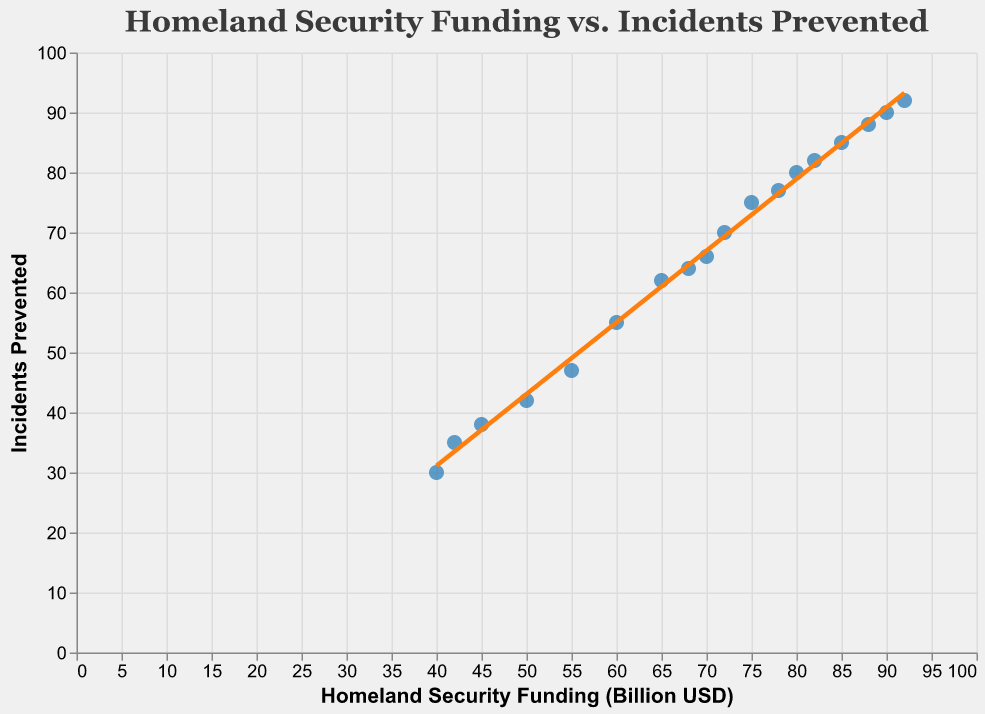How many data points are shown in the scatter plot? The scatter plot contains one data point for each fiscal year from 2005 to 2022. By counting these fiscal years, we find that there are 18 data points.
Answer: 18 What is the funding level for the year with the highest number of incidents prevented? The scatter plot shows a clear correlation where each fiscal year has increasing values for both funding and incidents prevented. The highest number of incidents prevented is 92 in 2022, where the funding is $92 billion USD.
Answer: $92 billion USD Is there any year where the incidents prevented are more than the funding in billion USD? By analyzing the data points, we observe that incidents prevented are always less than or equal to the funding provided in billion USD for each year.
Answer: No What is the trend line suggesting about the relationship between funding and incidents prevented? The trend line in the scatter plot shows a positive linear relationship, indicating that as homeland security funding increases, the number of incidents prevented also increases. The trend line enforces this correlation statistically.
Answer: Positive linear relationship Which year shows a funding of 75 billion USD and how many incidents were prevented that year? From the scatter plot, look for the data point where the x-axis shows 75 billion USD. Here, the corresponding y-axis value is 75 incidents prevented, which occurs in the year 2015.
Answer: 2015, 75 incidents How does the number of incidents prevented change from 2005 to 2022? The scatter plot shows that in 2005, 30 incidents were prevented, and in 2022, 92 incidents were prevented. Subtracting these values gives the change: 92 - 30 = 62 incidents.
Answer: Increased by 62 incidents In which year did the incidents prevented first reach 70? By checking the y-axis for the value 70 in the scatter plot, we find that the corresponding x-axis value is 72 billion USD, which is for the year 2014.
Answer: 2014 What's the average homeland security funding over the years 2005 to 2022? Sum the funding values from 2005 to 2022 and divide by the number of years (18). The total funding is (40 + 42 + 45 + 50 + 55 + 60 + 65 + 68 + 70 + 72 + 75 + 78 + 80 + 82 + 85 + 88 + 90 + 92) = 1247 billion USD. The average is 1247 / 18 = 69.28 billion USD.
Answer: 69.28 billion USD Compare the incidents prevented in 2010 and 2020. What is the difference? According to the scatter plot, in 2010, 55 incidents were prevented, and in 2020, 88 incidents were prevented. Subtracting these gives the difference: 88 - 55 = 33 incidents.
Answer: 33 incidents Is there any noticeable outlier in the relationship between funding and incidents prevented? Observing the scatter plot, the data points closely follow the trend line without any significant deviation, indicating there are no noticeable outliers.
Answer: No 